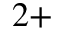Convert formula to latex. <formula><loc_0><loc_0><loc_500><loc_500>^ { 2 + }</formula> 